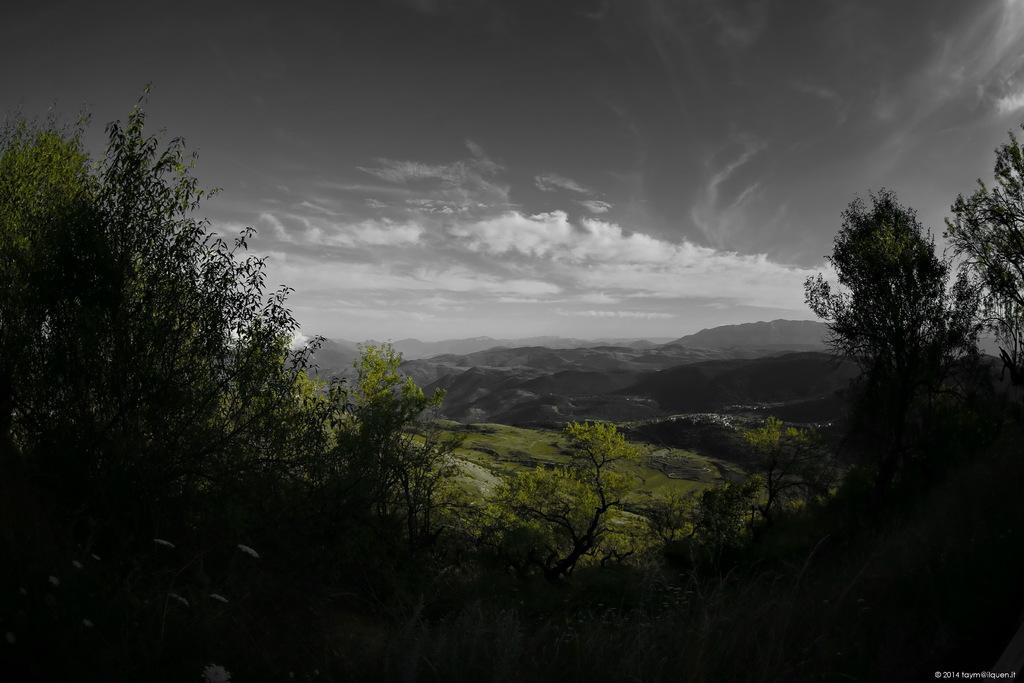Can you describe this image briefly? In this image we can see trees. In the background there are hills and sky. 